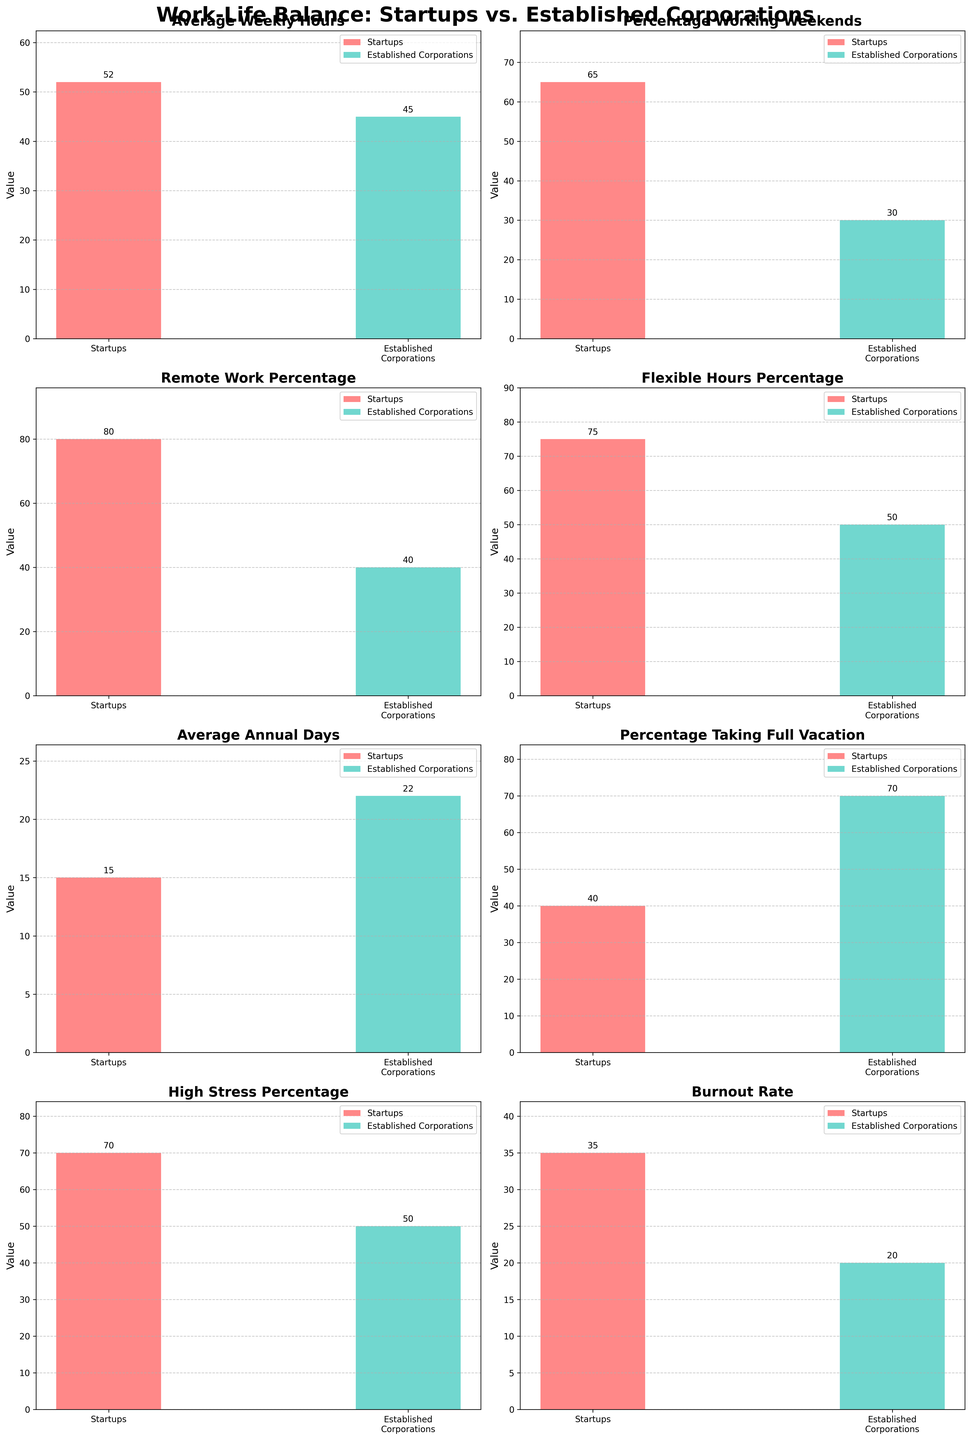What is the difference in the average weekly hours worked between startups and established corporations? To find the difference, look at the bar heights for "Average Weekly Hours" in both startups and established corporations. The startups have 52 average weekly hours, and the established corporations have 45. Subtract 45 from 52 to get the difference.
Answer: 7 Which company type has a higher percentage of employees working weekends, and by how much? Examine the bar heights for "Percentage Working Weekends". Startups show 65%, while established corporations show 30%. Subtract 30 from 65 to find the difference.
Answer: Startups, 35% In terms of remote work, how much higher is the percentage in startups compared to established corporations? Look at the "Remote Work Percentage" bars. Startups have 80%, whereas established corporations have 40%. Subtract 40 from 80 to get the difference.
Answer: 40% Which company type reports a higher burnout rate, and what is the percentage difference? Find the burnout rate values in the "Burnout Rate". Startups show 35%, and established corporations show 20%. Subtract 20 from 35 to get the difference.
Answer: Startups, 15% What is the combined average annual vacation days for both startups and established corporations? Add the bar heights for "Average Annual Days". Startups have 15 days, and established corporations have 22 days. Add these together.
Answer: 37 days Which company type has a higher "Work-Life Balance Satisfaction" rate, and by how much? Compare the bars for "Work-Life Balance Satisfaction". Established corporations have a 70% rate, while startups have a 55% rate. Subtract 55 from 70 to get the difference.
Answer: Established Corporations, 15% By how many years do startups promote faster compared to established corporations? Check the "Promotion Speed (Years)" bars. Startups take 2 years, whereas established corporations take 4 years. Subtract 2 from 4.
Answer: 2 years Which has a higher overall job satisfaction rate, startups or established corporations? Compare the "Overall Satisfaction Rate" bars. Startups have a rate of 72%, while established corporations have a rate of 68%.
Answer: Startups How much higher is the "Always-On Culture Percentage" in startups compared to established corporations? Look at the bars for "Always-On Culture Percentage". Startups have 75%, while established corporations have 40%. Subtract 40 from 75.
Answer: 35% For which company type is the percentage of employees taking full vacation days higher, and by how much? Examine the "Percentage Taking Full Vacation" bars. Established corporations have 70%, while startups have 40%. Subtract 40 from 70.
Answer: Established Corporations, 30% 